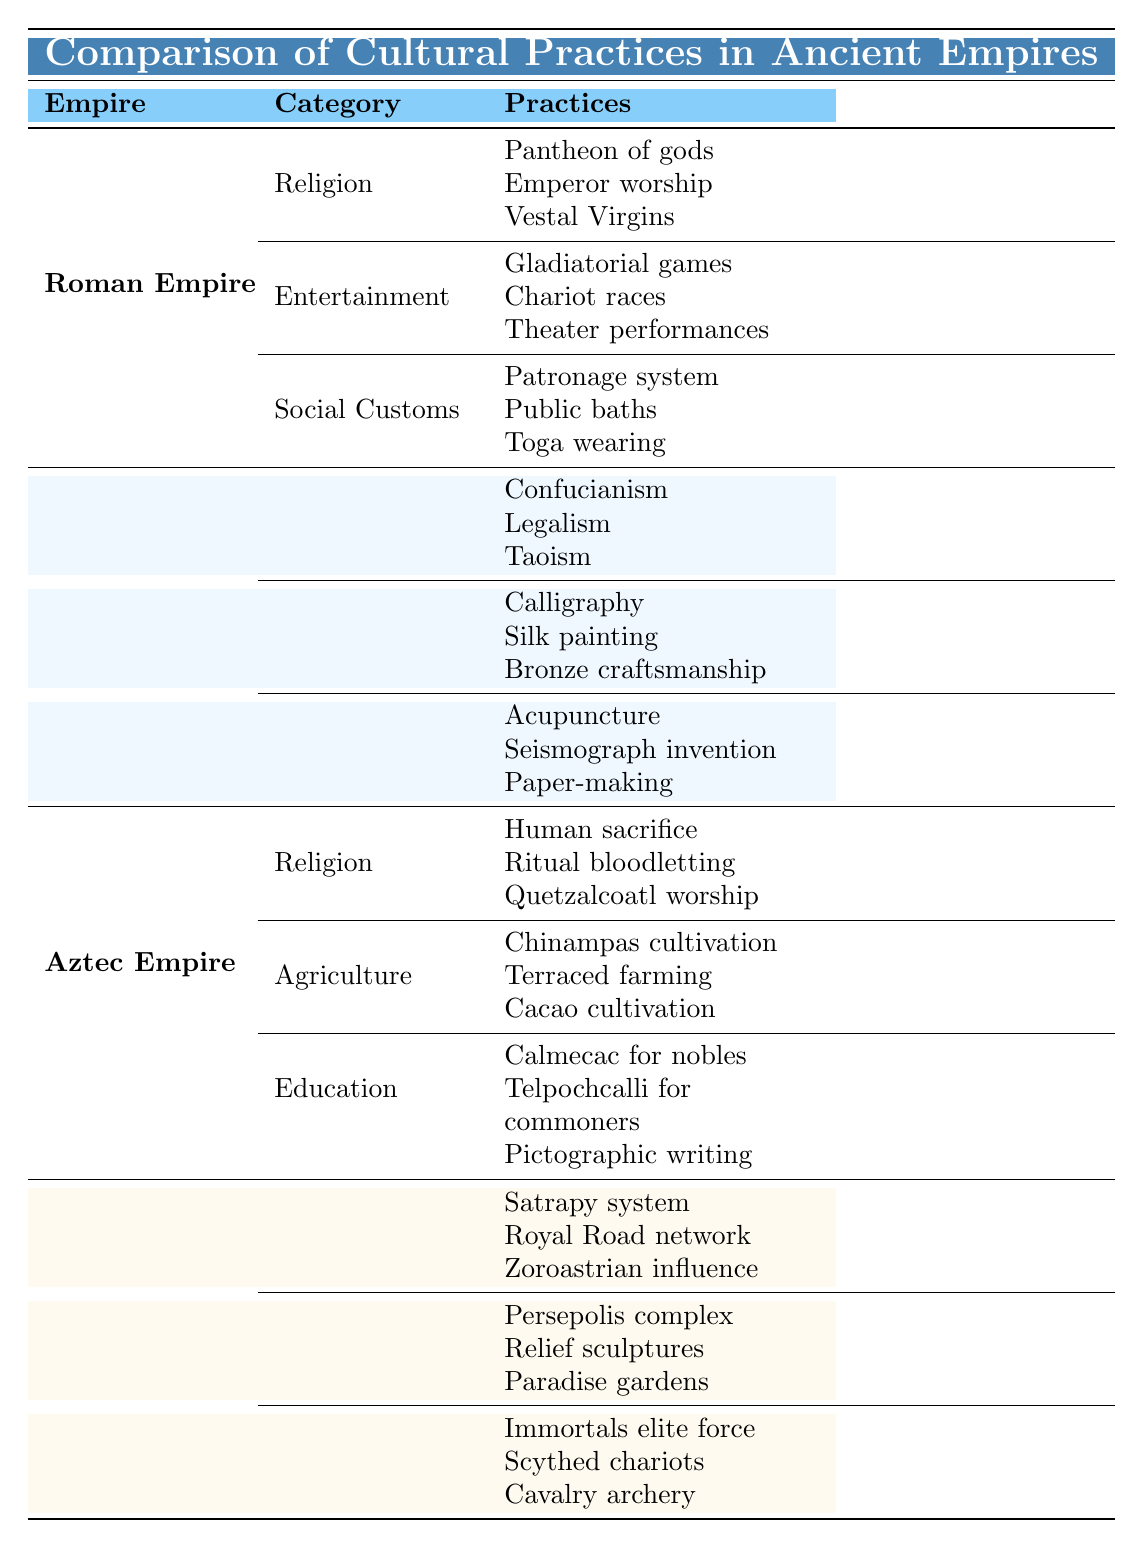What are the three categories of cultural practices in the Roman Empire? The table lists the Roman Empire's cultural practices under three categories: Religion, Entertainment, and Social Customs.
Answer: Religion, Entertainment, Social Customs How many practices are listed under the category of Education in the Aztec Empire? There are three practices listed under Education: Calmecac for nobles, Telpochcalli for commoners, and Pictographic writing.
Answer: 3 Does the Persian Empire have any cultural practices related to Science? The table does not list any Scientific practices under the Persian Empire; it only includes Governance, Art and Architecture, and Military.
Answer: No Which empire practiced human sacrifice as part of their religious customs? The Aztec Empire practiced human sacrifice, as clearly noted in the Religious category.
Answer: Aztec Empire What is the total number of practices listed for the Han Dynasty? There are three categories in the Han Dynasty (Philosophy, Arts, Science), with three practices listed under each, giving a total of 3 x 3 = 9 practices.
Answer: 9 Are there more cultural practices in the Roman Empire or the Han Dynasty? The Roman Empire has 9 cultural practices listed, while the Han Dynasty also has 9, which means they have the same number.
Answer: They are equal Which empire includes the practice of Chariot races under Entertainment? The practice of Chariot races is mentioned under the Entertainment category of the Roman Empire.
Answer: Roman Empire In terms of military practices, which empire features the Immortals elite force? The Immortals elite force is listed under the Military practices of the Persian Empire.
Answer: Persian Empire How do the religious practices of the Han Dynasty compare to those of the Aztec Empire? The Han Dynasty is noted for philosophical practices, while the Aztec Empire includes acts like human sacrifice, indicating a significant difference in focus and type of practices.
Answer: They are very different What is the main cultural focus of the Han Dynasty based on the practices listed? The Han Dynasty emphasizes philosophy, arts, and scientific advancements, showing a balanced cultural focus.
Answer: Philosophy, Arts, Science 